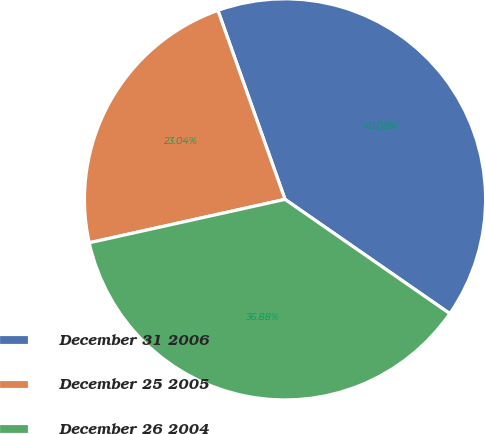Convert chart. <chart><loc_0><loc_0><loc_500><loc_500><pie_chart><fcel>December 31 2006<fcel>December 25 2005<fcel>December 26 2004<nl><fcel>40.08%<fcel>23.04%<fcel>36.88%<nl></chart> 